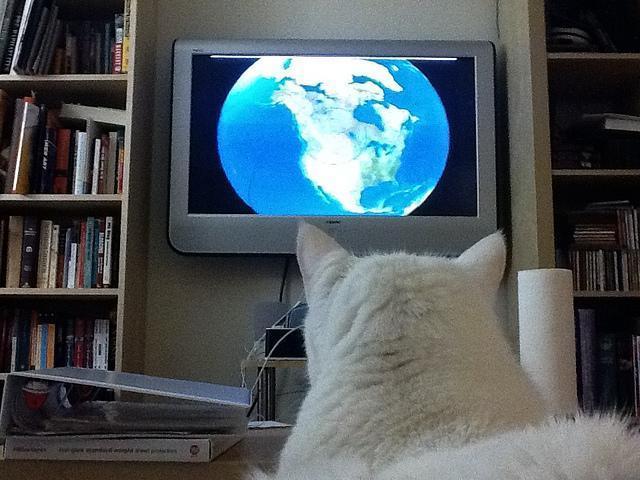How many people are on the TV screen?
Give a very brief answer. 0. 